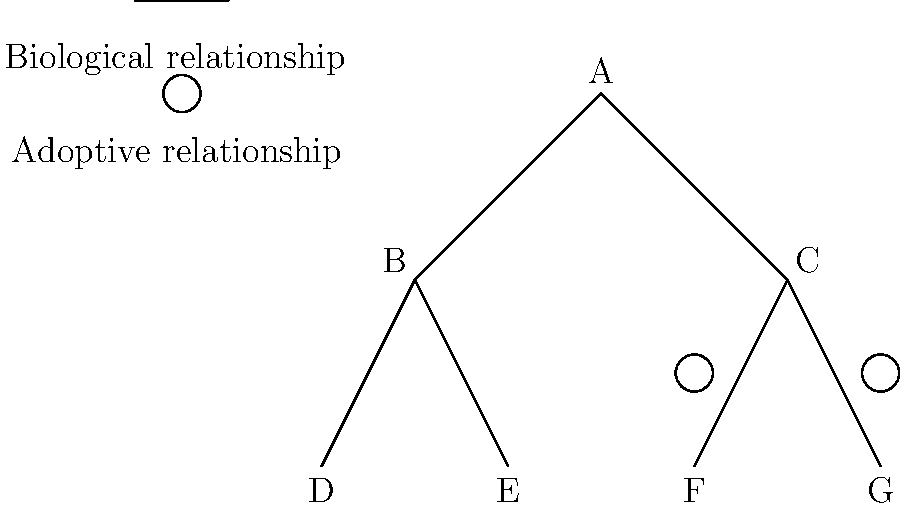In the family tree diagram above, person A is the parent of B and C. B has two children, D and E, while C has two adopted children, F and G. How many biological grandchildren does A have? To determine the number of biological grandchildren A has, we need to analyze the relationships in the family tree:

1. A is the parent of B and C.
2. B has two children, D and E, connected by straight lines, indicating biological relationships.
3. C has two children, F and G, but they are connected by lines with circles, indicating adoptive relationships.

Therefore:
- D and E are biological children of B, making them biological grandchildren of A.
- F and G are adopted children of C, so they are not biological grandchildren of A.

Counting the biological grandchildren:
$$ \text{Biological grandchildren} = \text{B's biological children} = 2 $$
Answer: 2 